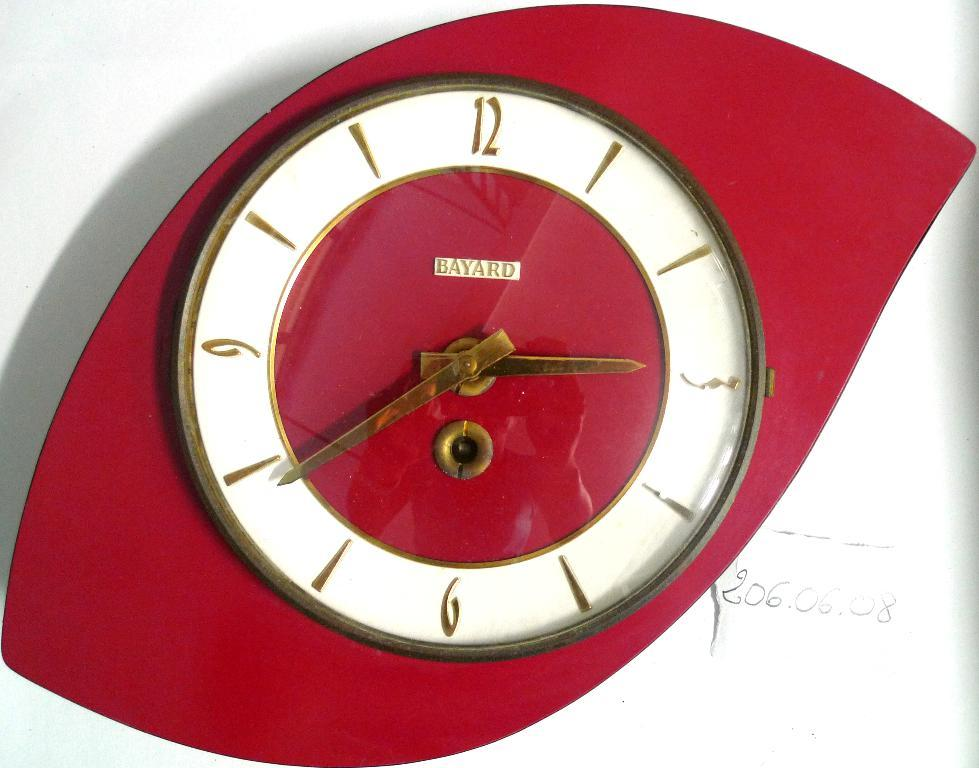<image>
Provide a brief description of the given image. Red and white clock that has the name BAYARD on it. 